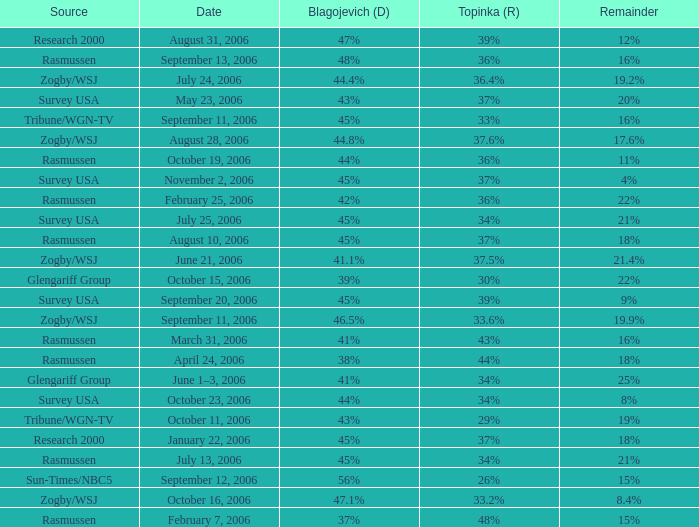Which Date has a Remainder of 20%? May 23, 2006. 